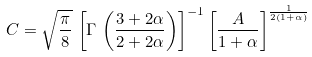Convert formula to latex. <formula><loc_0><loc_0><loc_500><loc_500>C = \sqrt { \frac { \pi } { 8 } } \, \left [ \Gamma \, \left ( \frac { 3 + 2 \alpha } { 2 + 2 \alpha } \right ) \right ] ^ { - 1 } \left [ \frac { A } { 1 + \alpha } \right ] ^ { \frac { 1 } { 2 ( 1 + \alpha ) } }</formula> 